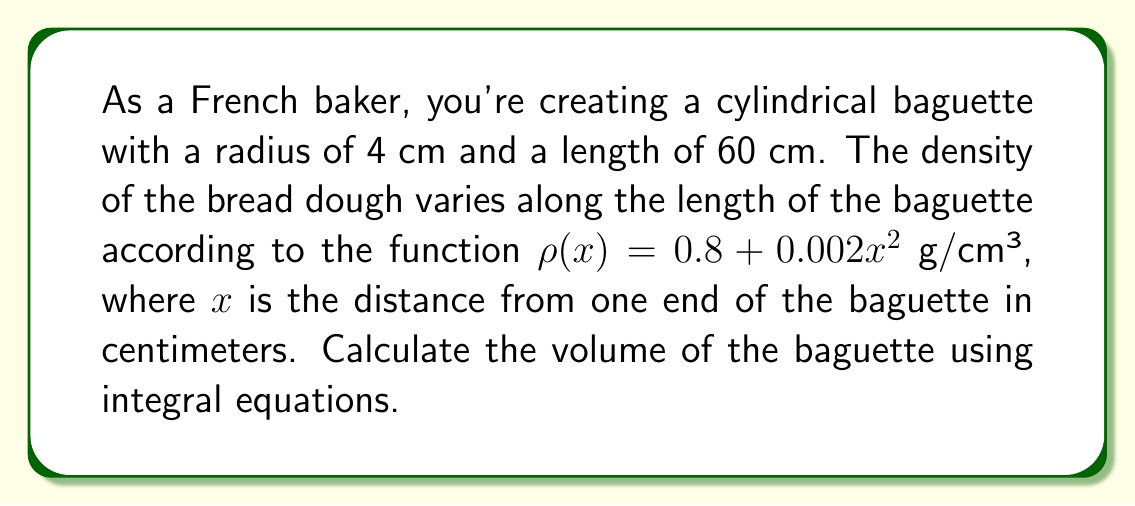What is the answer to this math problem? To calculate the volume of the cylindrical baguette using integral equations, we'll follow these steps:

1) The volume of a cylinder is generally given by the formula $V = \pi r^2 h$, where $r$ is the radius and $h$ is the height (or length in this case).

2) However, since the density varies along the length, we need to use an integral to account for this variation. We'll integrate over the length of the baguette.

3) The volume element $dV$ for a thin slice of the cylinder is:

   $dV = \pi r^2 dx$

4) To find the total volume, we integrate this element from $x = 0$ to $x = 60$ (the length of the baguette):

   $$V = \int_0^{60} \pi r^2 dx$$

5) We know that $r = 4$ cm, so we can substitute this:

   $$V = \int_0^{60} \pi (4\text{ cm})^2 dx$$

6) Simplify:

   $$V = 16\pi \int_0^{60} dx \text{ cm}^3$$

7) Evaluate the integral:

   $$V = 16\pi [x]_0^{60} \text{ cm}^3 = 16\pi (60 - 0) \text{ cm}^3 = 960\pi \text{ cm}^3$$

8) Calculate the final value:

   $$V \approx 3015.93 \text{ cm}^3$$

Note: The density function $\rho(x)$ given in the problem is not needed for volume calculation. It would be used if we were calculating the mass of the baguette.
Answer: $960\pi \text{ cm}^3$ or approximately $3015.93 \text{ cm}^3$ 